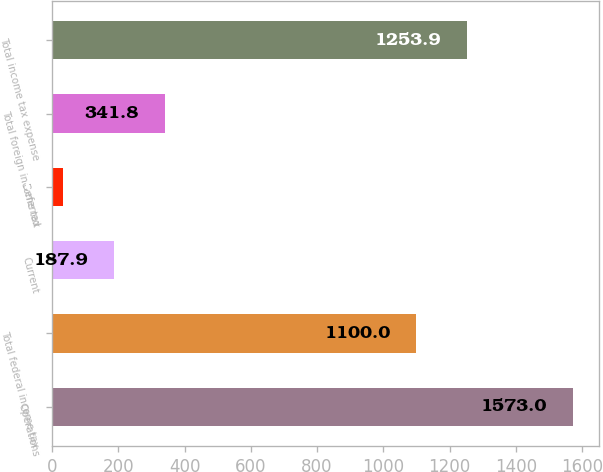Convert chart. <chart><loc_0><loc_0><loc_500><loc_500><bar_chart><fcel>Operations<fcel>Total federal income tax<fcel>Current<fcel>Deferred<fcel>Total foreign income tax<fcel>Total income tax expense<nl><fcel>1573<fcel>1100<fcel>187.9<fcel>34<fcel>341.8<fcel>1253.9<nl></chart> 